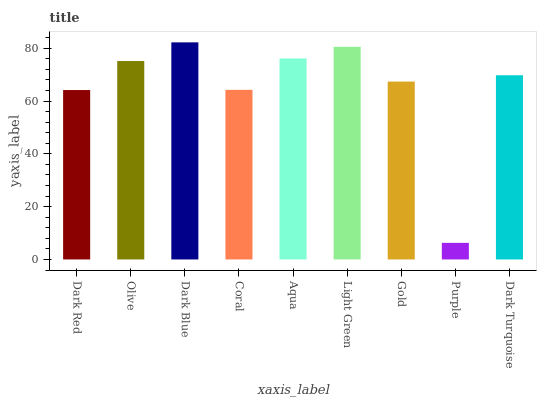Is Purple the minimum?
Answer yes or no. Yes. Is Dark Blue the maximum?
Answer yes or no. Yes. Is Olive the minimum?
Answer yes or no. No. Is Olive the maximum?
Answer yes or no. No. Is Olive greater than Dark Red?
Answer yes or no. Yes. Is Dark Red less than Olive?
Answer yes or no. Yes. Is Dark Red greater than Olive?
Answer yes or no. No. Is Olive less than Dark Red?
Answer yes or no. No. Is Dark Turquoise the high median?
Answer yes or no. Yes. Is Dark Turquoise the low median?
Answer yes or no. Yes. Is Coral the high median?
Answer yes or no. No. Is Purple the low median?
Answer yes or no. No. 